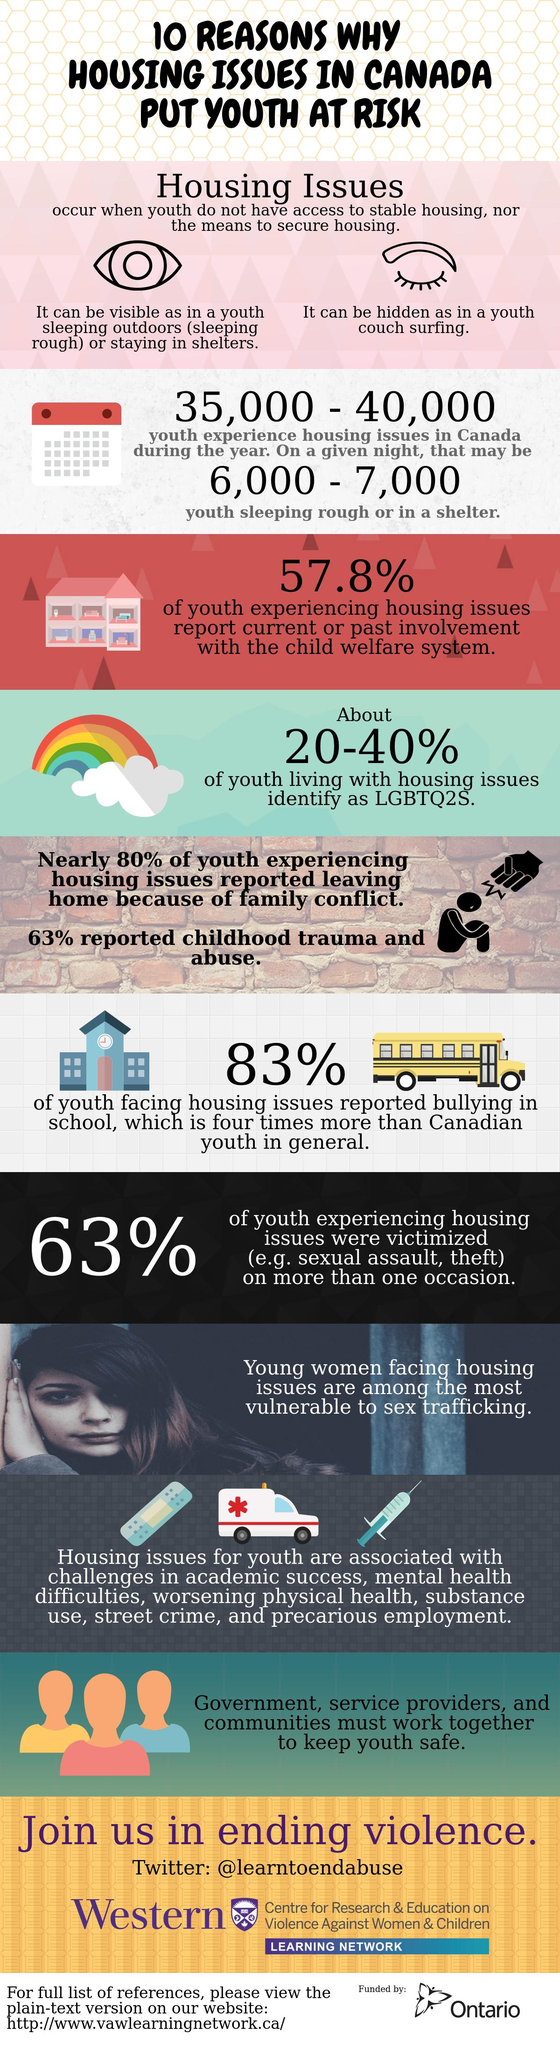Indicate a few pertinent items in this graphic. In Canada, a staggering 83% of youth have experienced housing issues and faced bullying in school. In Canada, it is estimated that 80% of youth are leaving home due to parental conflict. According to estimates, 20-40% of youth in Canada who identify as LGBTQ2S also face housing issues. 